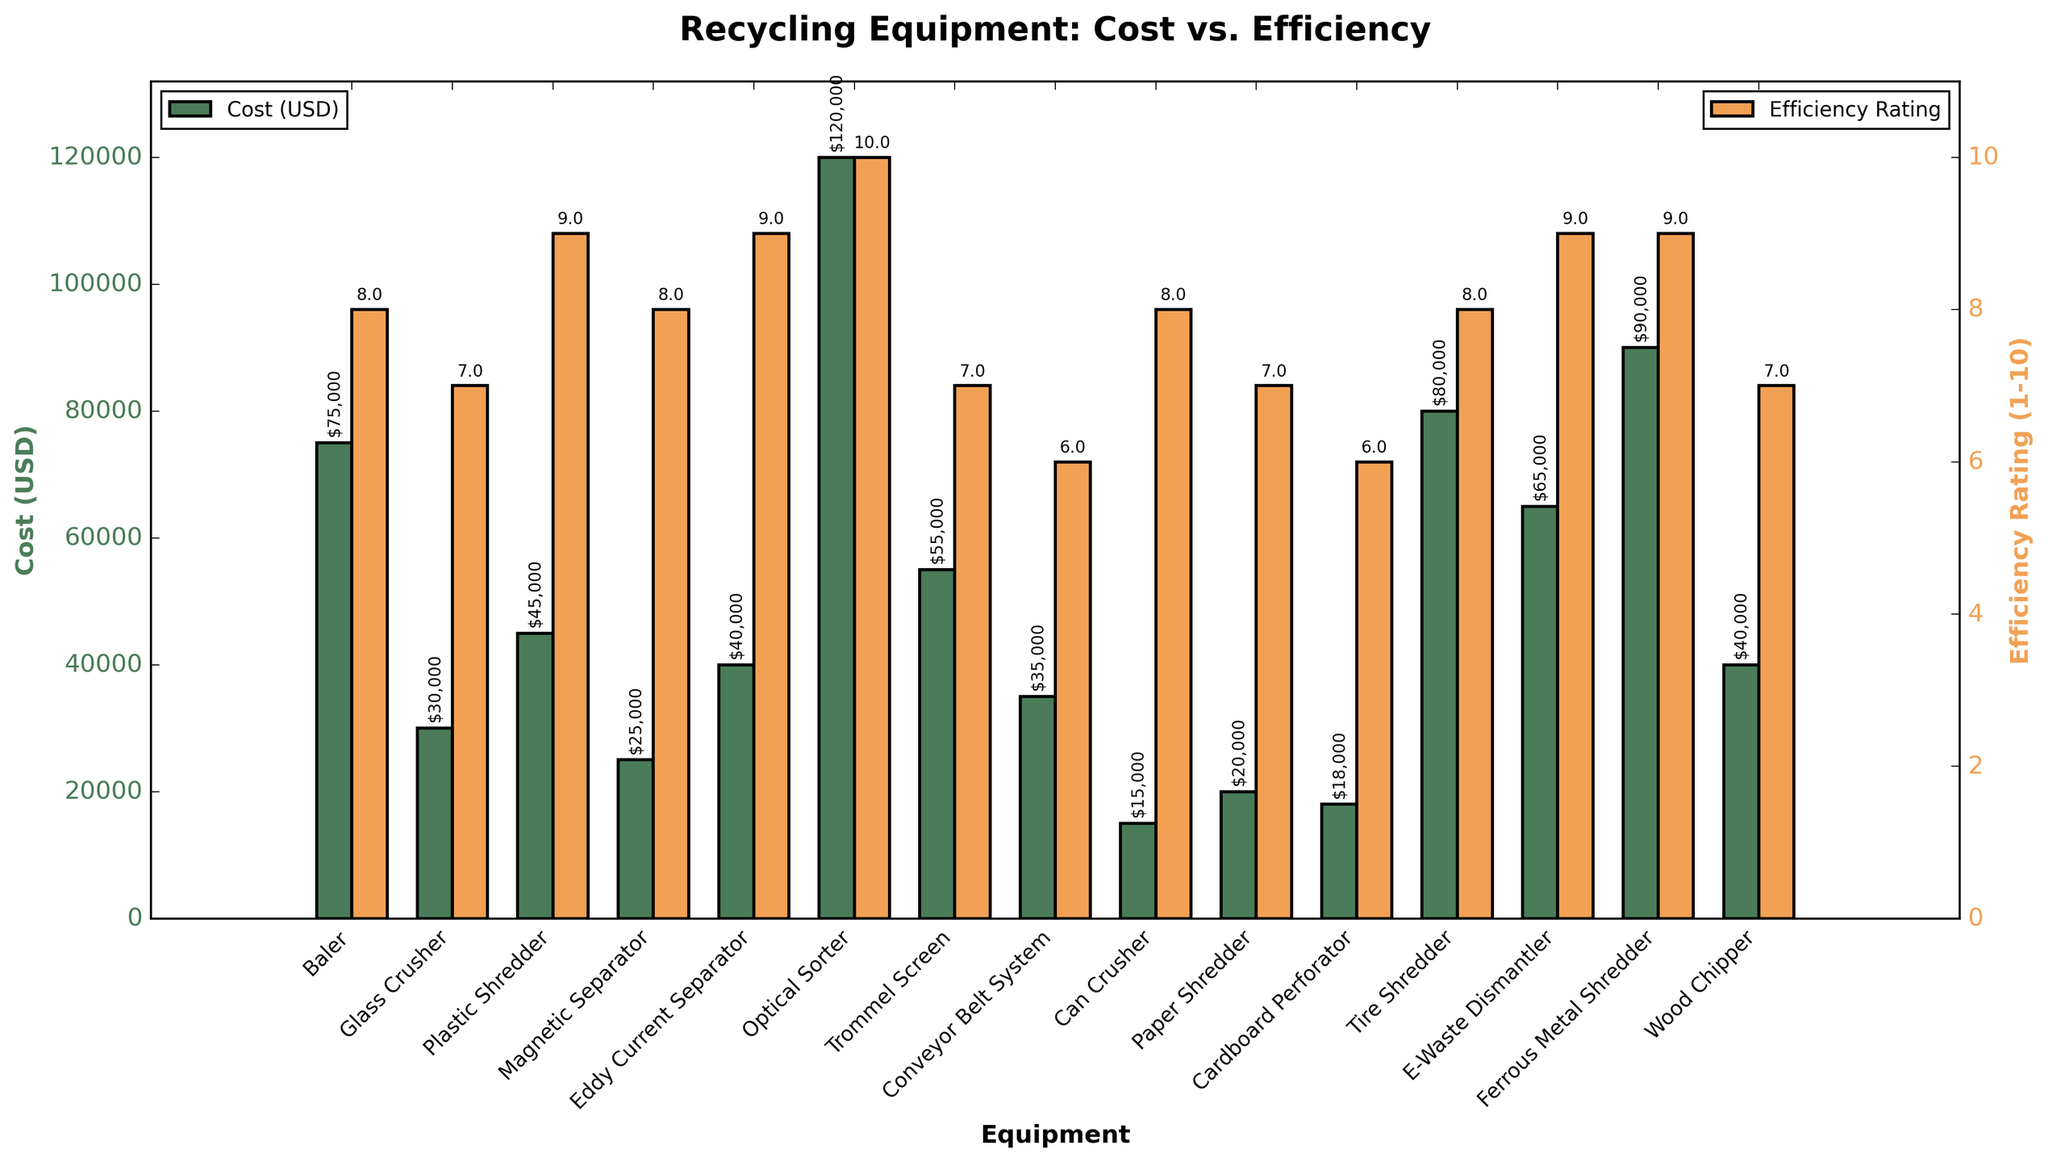Which equipment has the highest cost? By observing the height of the bars representing costs, we can see that the 'Optical Sorter' has the tallest bar, indicating the highest cost.
Answer: Optical Sorter Which equipment has the highest efficiency rating? By looking at the chart for the highest bars on the right y-axis representing efficiency ratings, we see the 'Optical Sorter' again has the tallest bar with a rating of 10.
Answer: Optical Sorter What is the cost difference between the 'Baler' and the 'Glass Crusher'? The cost of the 'Baler' is $75,000 and the cost of the 'Glass Crusher' is $30,000. Subtracting the smaller from the larger figure, $75,000 - $30,000 = $45,000.
Answer: $45,000 Which equipment has both the lowest cost and an efficiency rating above 7? We need to find the bar with the lowest height representing cost on the left y-axis, and cross-check the efficiency rating from the right y-axis. The 'Can Crusher' costs $15,000 and has an efficiency rating of 8.
Answer: Can Crusher What is the average cost of the equipment with an efficiency rating of 7? The equipment with a rating of 7 are 'Glass Crusher', 'Trommel Screen', 'Paper Shredder', and 'Wood Chipper'. Their costs are $30,000, $55,000, $20,000, and $40,000. Total cost is $30,000 + $55,000 + $20,000 + $40,000 = $145,000. There are 4 pieces of equipment, so the average cost is $145,000 / 4 = $36,250.
Answer: $36,250 Which equipment has an efficiency rating equal to the 'Plastic Shredder'? The 'Plastic Shredder' has an efficiency rating of 9. The other equipment with a rating of 9 are 'Eddy Current Separator', 'E-Waste Dismantler', and 'Ferrous Metal Shredder'.
Answer: Eddy Current Separator, E-Waste Dismantler, Ferrous Metal Shredder What is the total efficiency rating for all the equipment combined? Adding up the efficiency ratings: 8 + 7 + 9 + 8 + 9 + 10 + 7 + 6 + 8 + 7 + 6 + 8 + 9 + 9 + 7 = 118.
Answer: 118 Between 'Tire Shredder' and 'Conveyor Belt System', which has a higher cost and by how much? The 'Tire Shredder' costs $80,000, and the 'Conveyor Belt System' costs $35,000. The difference in cost is $80,000 - $35,000 = $45,000.
Answer: Tire Shredder by $45,000 Which equipment costing over $40,000 has the lowest efficiency rating? Examining the bars representing equipment with costs above $40,000, and checking their efficiency ratings, we see 'Trommel Screen' has a cost of $55,000 and an efficiency rating of 7, which is the lowest among them.
Answer: Trommel Screen What is the sum of the costs of all equipment that have an efficiency rating of 8? The equipment are 'Baler', 'Magnetic Separator', 'Can Crusher', and 'Tire Shredder', with costs $75,000, $25,000, $15,000, and $80,000 respectively. Summing these values: $75,000 + $25,000 + $15,000 + $80,000 = $195,000.
Answer: $195,000 